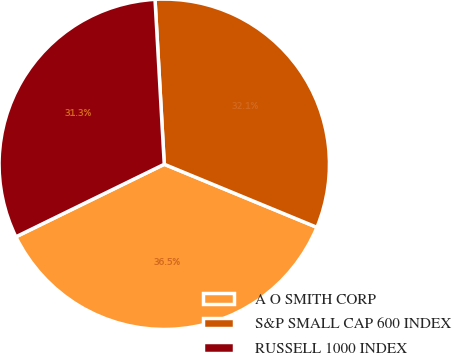<chart> <loc_0><loc_0><loc_500><loc_500><pie_chart><fcel>A O SMITH CORP<fcel>S&P SMALL CAP 600 INDEX<fcel>RUSSELL 1000 INDEX<nl><fcel>36.53%<fcel>32.13%<fcel>31.35%<nl></chart> 